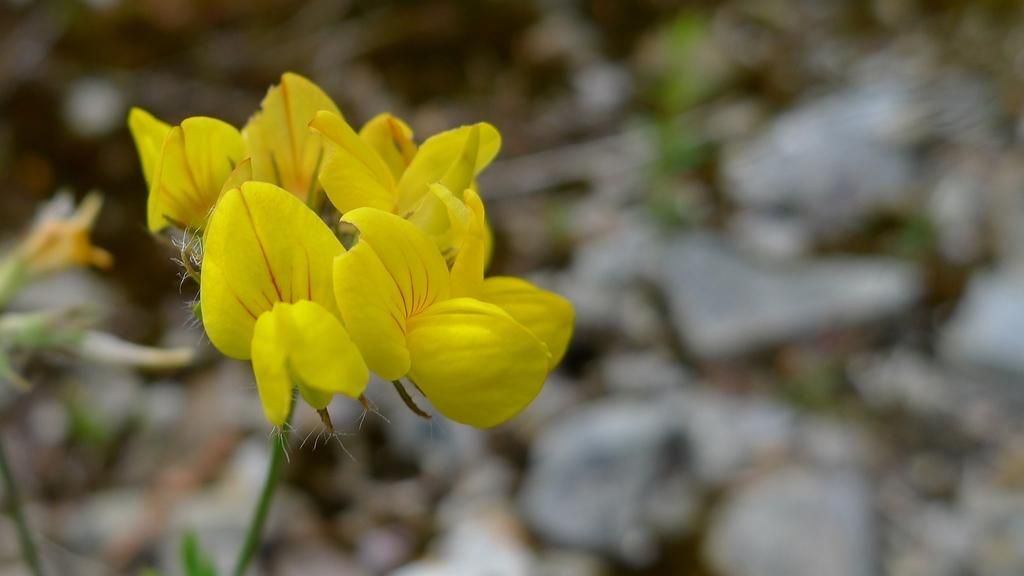What is the main subject of the image? The main subject of the image is flowers. Where are the flowers located in the image? The flowers are in the center of the image. What color are the flowers? The flowers are yellow in color. What type of flame can be seen burning in the image? There is no flame present in the image; it features yellow flowers in the center. Can you describe the bird that is flying above the flowers in the image? There is no bird present in the image; it only features yellow flowers in the center. 